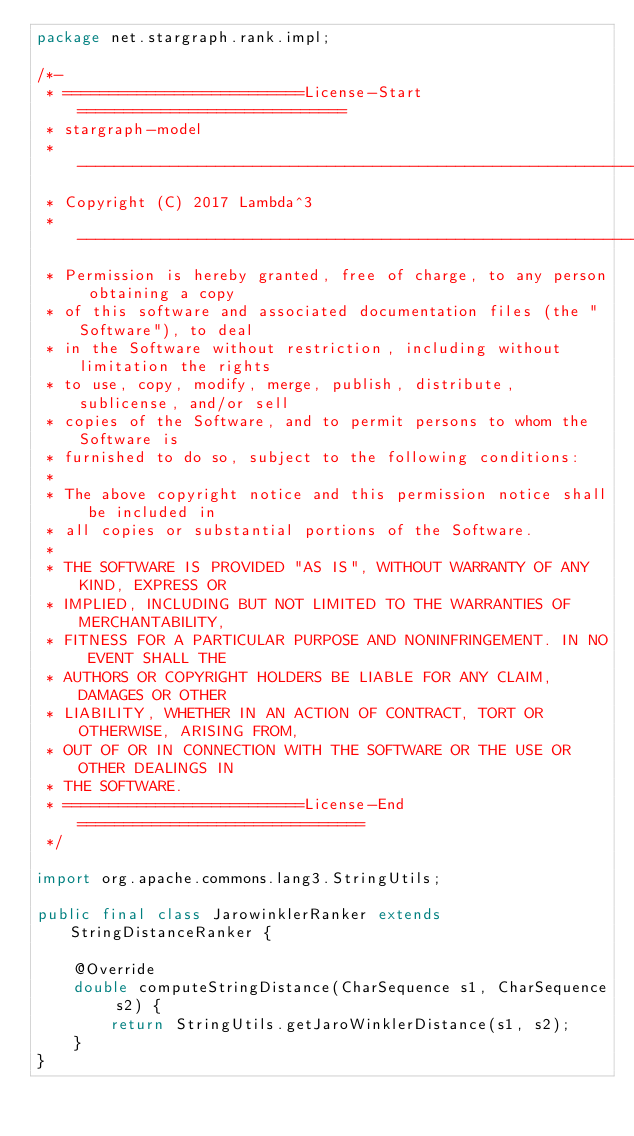Convert code to text. <code><loc_0><loc_0><loc_500><loc_500><_Java_>package net.stargraph.rank.impl;

/*-
 * ==========================License-Start=============================
 * stargraph-model
 * --------------------------------------------------------------------
 * Copyright (C) 2017 Lambda^3
 * --------------------------------------------------------------------
 * Permission is hereby granted, free of charge, to any person obtaining a copy
 * of this software and associated documentation files (the "Software"), to deal
 * in the Software without restriction, including without limitation the rights
 * to use, copy, modify, merge, publish, distribute, sublicense, and/or sell
 * copies of the Software, and to permit persons to whom the Software is
 * furnished to do so, subject to the following conditions:
 * 
 * The above copyright notice and this permission notice shall be included in
 * all copies or substantial portions of the Software.
 * 
 * THE SOFTWARE IS PROVIDED "AS IS", WITHOUT WARRANTY OF ANY KIND, EXPRESS OR
 * IMPLIED, INCLUDING BUT NOT LIMITED TO THE WARRANTIES OF MERCHANTABILITY,
 * FITNESS FOR A PARTICULAR PURPOSE AND NONINFRINGEMENT. IN NO EVENT SHALL THE
 * AUTHORS OR COPYRIGHT HOLDERS BE LIABLE FOR ANY CLAIM, DAMAGES OR OTHER
 * LIABILITY, WHETHER IN AN ACTION OF CONTRACT, TORT OR OTHERWISE, ARISING FROM,
 * OUT OF OR IN CONNECTION WITH THE SOFTWARE OR THE USE OR OTHER DEALINGS IN
 * THE SOFTWARE.
 * ==========================License-End===============================
 */

import org.apache.commons.lang3.StringUtils;

public final class JarowinklerRanker extends StringDistanceRanker {

    @Override
    double computeStringDistance(CharSequence s1, CharSequence s2) {
        return StringUtils.getJaroWinklerDistance(s1, s2);
    }
}
</code> 